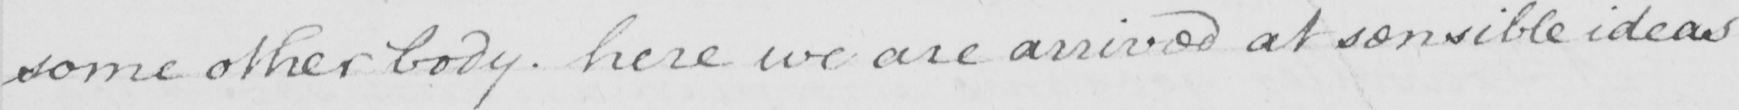What is written in this line of handwriting? some other body . here we are arrived at sensible ideas 